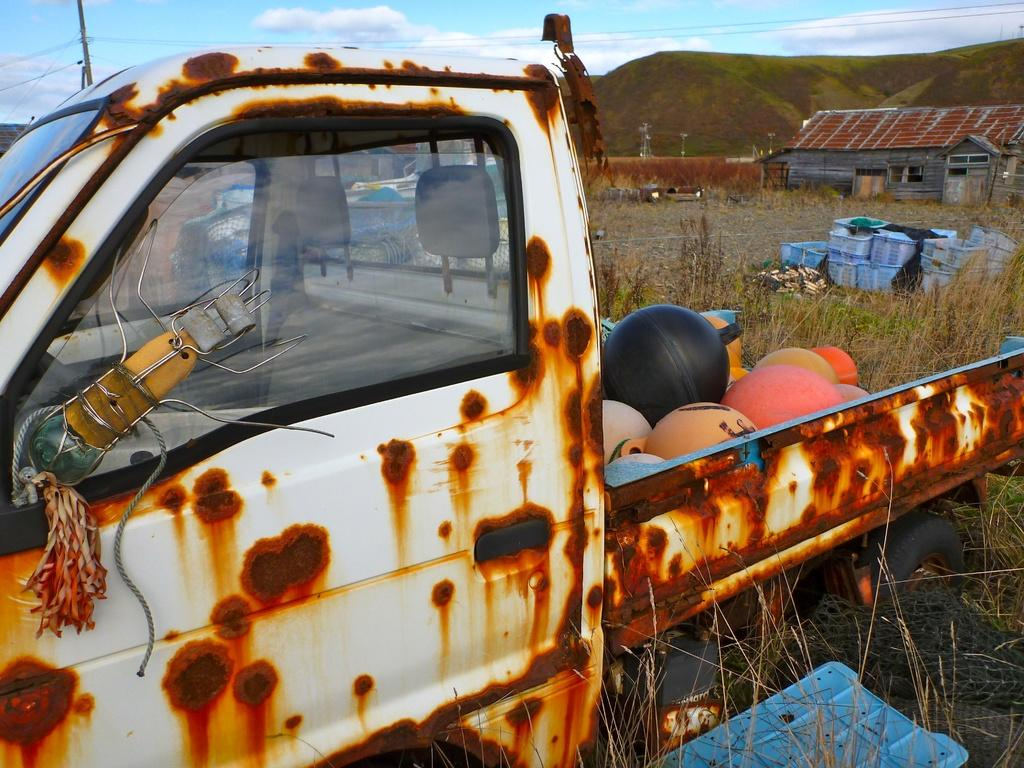What is the main subject of the image? There is a van in a field in the image. What can be seen inside the van? There are objects inside the van. What is visible in the background of the image? There are boxes, a house, mountains, and the sky visible in the background. What type of plantation can be seen near the van in the image? There is no plantation present in the image; it features a van in a field with various objects inside and a background that includes boxes, a house, mountains, and the sky. 